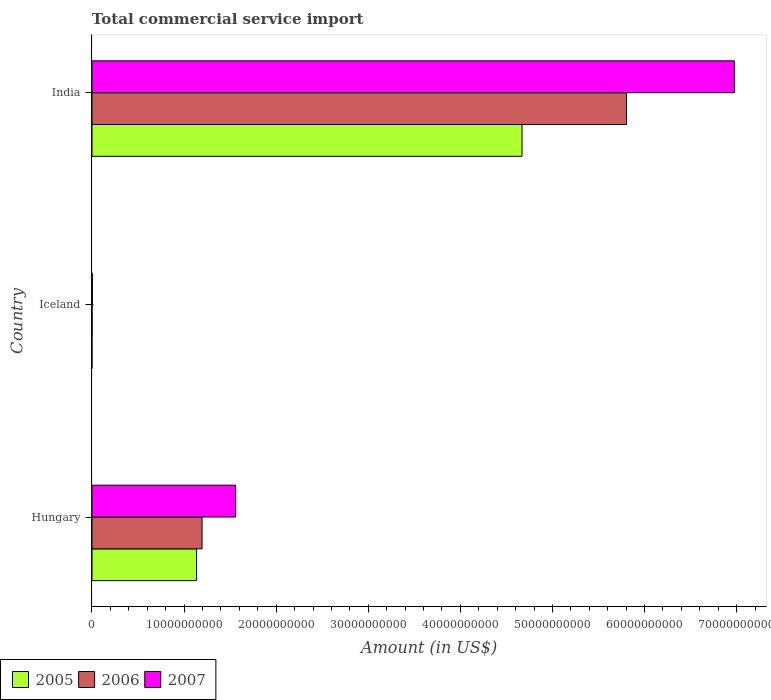How many different coloured bars are there?
Make the answer very short. 3. How many groups of bars are there?
Provide a succinct answer. 3. Are the number of bars per tick equal to the number of legend labels?
Provide a short and direct response. No. How many bars are there on the 2nd tick from the top?
Keep it short and to the point. 2. How many bars are there on the 3rd tick from the bottom?
Keep it short and to the point. 3. What is the label of the 3rd group of bars from the top?
Your answer should be very brief. Hungary. What is the total commercial service import in 2007 in Hungary?
Give a very brief answer. 1.56e+1. Across all countries, what is the maximum total commercial service import in 2007?
Offer a terse response. 6.98e+1. Across all countries, what is the minimum total commercial service import in 2007?
Make the answer very short. 3.38e+07. In which country was the total commercial service import in 2006 maximum?
Provide a short and direct response. India. What is the total total commercial service import in 2005 in the graph?
Your answer should be compact. 5.81e+1. What is the difference between the total commercial service import in 2005 in Hungary and that in India?
Give a very brief answer. -3.53e+1. What is the difference between the total commercial service import in 2005 in India and the total commercial service import in 2006 in Iceland?
Provide a succinct answer. 4.67e+1. What is the average total commercial service import in 2007 per country?
Offer a terse response. 2.85e+1. What is the difference between the total commercial service import in 2007 and total commercial service import in 2006 in Hungary?
Offer a terse response. 3.65e+09. What is the ratio of the total commercial service import in 2007 in Hungary to that in India?
Offer a terse response. 0.22. Is the total commercial service import in 2007 in Hungary less than that in India?
Offer a terse response. Yes. Is the difference between the total commercial service import in 2007 in Hungary and Iceland greater than the difference between the total commercial service import in 2006 in Hungary and Iceland?
Make the answer very short. Yes. What is the difference between the highest and the second highest total commercial service import in 2006?
Your answer should be compact. 4.61e+1. What is the difference between the highest and the lowest total commercial service import in 2006?
Your answer should be very brief. 5.80e+1. Is it the case that in every country, the sum of the total commercial service import in 2006 and total commercial service import in 2005 is greater than the total commercial service import in 2007?
Offer a terse response. No. Are all the bars in the graph horizontal?
Your response must be concise. Yes. How many countries are there in the graph?
Offer a terse response. 3. Are the values on the major ticks of X-axis written in scientific E-notation?
Your response must be concise. No. Where does the legend appear in the graph?
Provide a short and direct response. Bottom left. What is the title of the graph?
Your response must be concise. Total commercial service import. Does "1978" appear as one of the legend labels in the graph?
Provide a succinct answer. No. What is the label or title of the Y-axis?
Your answer should be very brief. Country. What is the Amount (in US$) of 2005 in Hungary?
Your response must be concise. 1.14e+1. What is the Amount (in US$) of 2006 in Hungary?
Keep it short and to the point. 1.20e+1. What is the Amount (in US$) in 2007 in Hungary?
Make the answer very short. 1.56e+1. What is the Amount (in US$) in 2005 in Iceland?
Provide a succinct answer. 0. What is the Amount (in US$) of 2006 in Iceland?
Ensure brevity in your answer.  8.55e+06. What is the Amount (in US$) of 2007 in Iceland?
Offer a very short reply. 3.38e+07. What is the Amount (in US$) of 2005 in India?
Offer a terse response. 4.67e+1. What is the Amount (in US$) in 2006 in India?
Make the answer very short. 5.80e+1. What is the Amount (in US$) of 2007 in India?
Your answer should be compact. 6.98e+1. Across all countries, what is the maximum Amount (in US$) in 2005?
Give a very brief answer. 4.67e+1. Across all countries, what is the maximum Amount (in US$) of 2006?
Your response must be concise. 5.80e+1. Across all countries, what is the maximum Amount (in US$) of 2007?
Make the answer very short. 6.98e+1. Across all countries, what is the minimum Amount (in US$) in 2005?
Provide a succinct answer. 0. Across all countries, what is the minimum Amount (in US$) in 2006?
Offer a very short reply. 8.55e+06. Across all countries, what is the minimum Amount (in US$) of 2007?
Your answer should be very brief. 3.38e+07. What is the total Amount (in US$) in 2005 in the graph?
Your answer should be compact. 5.81e+1. What is the total Amount (in US$) of 2006 in the graph?
Your answer should be very brief. 7.00e+1. What is the total Amount (in US$) in 2007 in the graph?
Offer a very short reply. 8.54e+1. What is the difference between the Amount (in US$) of 2006 in Hungary and that in Iceland?
Offer a terse response. 1.19e+1. What is the difference between the Amount (in US$) in 2007 in Hungary and that in Iceland?
Provide a short and direct response. 1.56e+1. What is the difference between the Amount (in US$) in 2005 in Hungary and that in India?
Ensure brevity in your answer.  -3.53e+1. What is the difference between the Amount (in US$) in 2006 in Hungary and that in India?
Make the answer very short. -4.61e+1. What is the difference between the Amount (in US$) in 2007 in Hungary and that in India?
Provide a succinct answer. -5.42e+1. What is the difference between the Amount (in US$) of 2006 in Iceland and that in India?
Keep it short and to the point. -5.80e+1. What is the difference between the Amount (in US$) of 2007 in Iceland and that in India?
Offer a very short reply. -6.97e+1. What is the difference between the Amount (in US$) in 2005 in Hungary and the Amount (in US$) in 2006 in Iceland?
Make the answer very short. 1.14e+1. What is the difference between the Amount (in US$) in 2005 in Hungary and the Amount (in US$) in 2007 in Iceland?
Your answer should be very brief. 1.13e+1. What is the difference between the Amount (in US$) in 2006 in Hungary and the Amount (in US$) in 2007 in Iceland?
Your response must be concise. 1.19e+1. What is the difference between the Amount (in US$) of 2005 in Hungary and the Amount (in US$) of 2006 in India?
Make the answer very short. -4.67e+1. What is the difference between the Amount (in US$) of 2005 in Hungary and the Amount (in US$) of 2007 in India?
Provide a succinct answer. -5.84e+1. What is the difference between the Amount (in US$) of 2006 in Hungary and the Amount (in US$) of 2007 in India?
Your answer should be very brief. -5.78e+1. What is the difference between the Amount (in US$) of 2006 in Iceland and the Amount (in US$) of 2007 in India?
Provide a succinct answer. -6.97e+1. What is the average Amount (in US$) in 2005 per country?
Your response must be concise. 1.94e+1. What is the average Amount (in US$) in 2006 per country?
Offer a terse response. 2.33e+1. What is the average Amount (in US$) in 2007 per country?
Offer a terse response. 2.85e+1. What is the difference between the Amount (in US$) of 2005 and Amount (in US$) of 2006 in Hungary?
Offer a terse response. -5.91e+08. What is the difference between the Amount (in US$) of 2005 and Amount (in US$) of 2007 in Hungary?
Keep it short and to the point. -4.24e+09. What is the difference between the Amount (in US$) of 2006 and Amount (in US$) of 2007 in Hungary?
Keep it short and to the point. -3.65e+09. What is the difference between the Amount (in US$) in 2006 and Amount (in US$) in 2007 in Iceland?
Provide a short and direct response. -2.52e+07. What is the difference between the Amount (in US$) in 2005 and Amount (in US$) in 2006 in India?
Your answer should be compact. -1.13e+1. What is the difference between the Amount (in US$) in 2005 and Amount (in US$) in 2007 in India?
Give a very brief answer. -2.31e+1. What is the difference between the Amount (in US$) of 2006 and Amount (in US$) of 2007 in India?
Your response must be concise. -1.17e+1. What is the ratio of the Amount (in US$) of 2006 in Hungary to that in Iceland?
Provide a short and direct response. 1397.83. What is the ratio of the Amount (in US$) in 2007 in Hungary to that in Iceland?
Ensure brevity in your answer.  461.9. What is the ratio of the Amount (in US$) of 2005 in Hungary to that in India?
Ensure brevity in your answer.  0.24. What is the ratio of the Amount (in US$) of 2006 in Hungary to that in India?
Give a very brief answer. 0.21. What is the ratio of the Amount (in US$) of 2007 in Hungary to that in India?
Make the answer very short. 0.22. What is the ratio of the Amount (in US$) in 2006 in Iceland to that in India?
Ensure brevity in your answer.  0. What is the difference between the highest and the second highest Amount (in US$) of 2006?
Your answer should be compact. 4.61e+1. What is the difference between the highest and the second highest Amount (in US$) in 2007?
Offer a very short reply. 5.42e+1. What is the difference between the highest and the lowest Amount (in US$) in 2005?
Keep it short and to the point. 4.67e+1. What is the difference between the highest and the lowest Amount (in US$) in 2006?
Your response must be concise. 5.80e+1. What is the difference between the highest and the lowest Amount (in US$) in 2007?
Make the answer very short. 6.97e+1. 